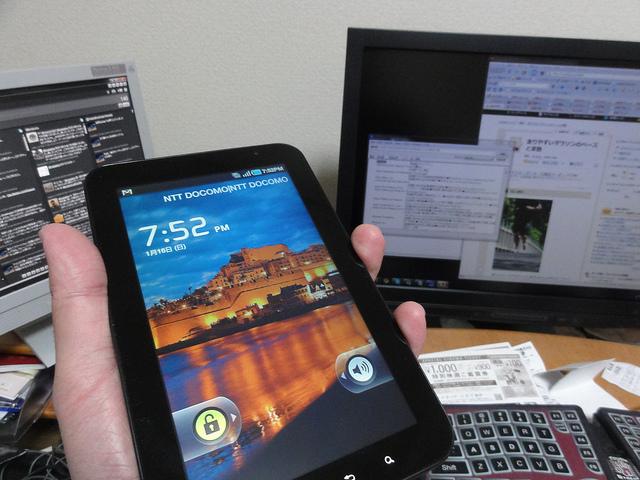What color is the tablet?
Answer briefly. Black. Is the phone locked?
Write a very short answer. Yes. Is this tablet an iPad?
Concise answer only. No. 